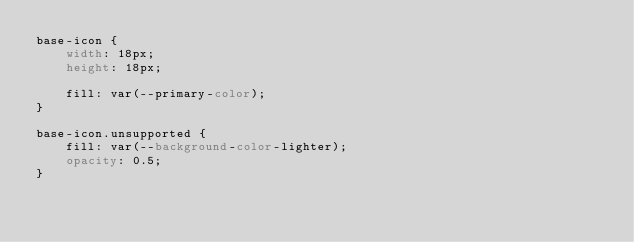<code> <loc_0><loc_0><loc_500><loc_500><_CSS_>base-icon {
    width: 18px;
    height: 18px;

    fill: var(--primary-color);
}

base-icon.unsupported {
    fill: var(--background-color-lighter);
    opacity: 0.5;
}
</code> 